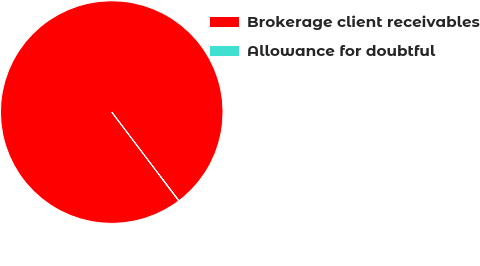<chart> <loc_0><loc_0><loc_500><loc_500><pie_chart><fcel>Brokerage client receivables<fcel>Allowance for doubtful<nl><fcel>99.99%<fcel>0.01%<nl></chart> 